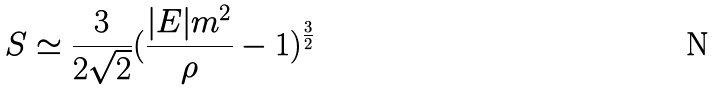<formula> <loc_0><loc_0><loc_500><loc_500>S \simeq \frac { 3 } { 2 \sqrt { 2 } } ( \frac { | E | m ^ { 2 } } { \rho } - 1 ) ^ { \frac { 3 } { 2 } }</formula> 